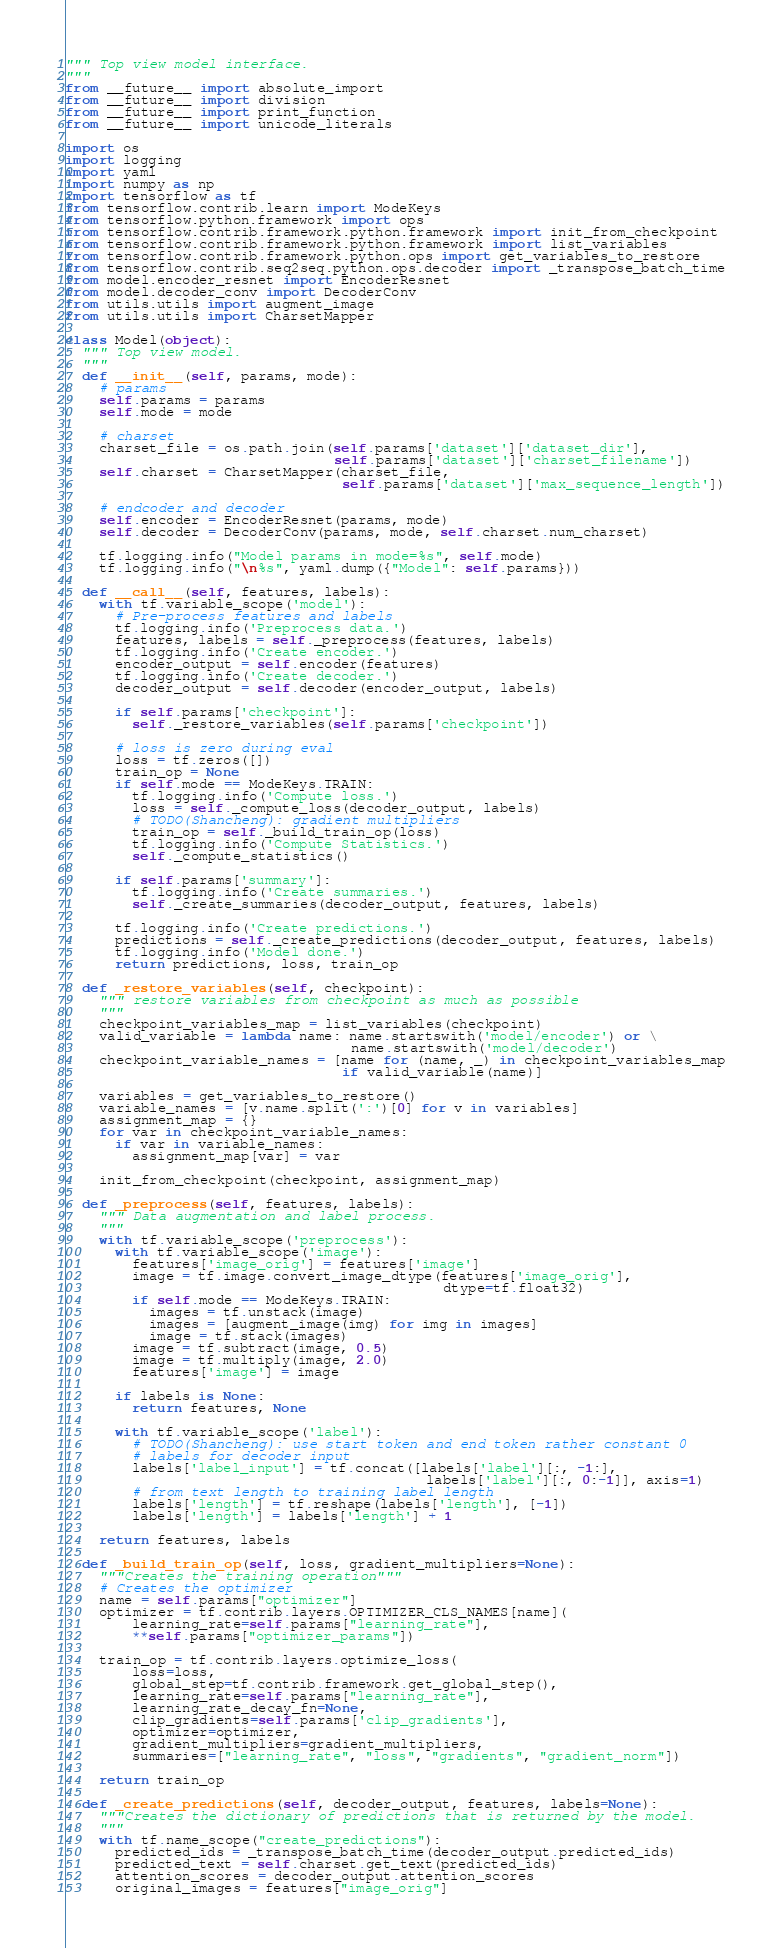<code> <loc_0><loc_0><loc_500><loc_500><_Python_>""" Top view model interface.
"""
from __future__ import absolute_import
from __future__ import division
from __future__ import print_function
from __future__ import unicode_literals

import os
import logging
import yaml
import numpy as np
import tensorflow as tf
from tensorflow.contrib.learn import ModeKeys
from tensorflow.python.framework import ops
from tensorflow.contrib.framework.python.framework import init_from_checkpoint
from tensorflow.contrib.framework.python.framework import list_variables
from tensorflow.contrib.framework.python.ops import get_variables_to_restore
from tensorflow.contrib.seq2seq.python.ops.decoder import _transpose_batch_time
from model.encoder_resnet import EncoderResnet
from model.decoder_conv import DecoderConv
from utils.utils import augment_image
from utils.utils import CharsetMapper

class Model(object):
  """ Top view model.
  """
  def __init__(self, params, mode):
    # params
    self.params = params
    self.mode = mode

    # charset
    charset_file = os.path.join(self.params['dataset']['dataset_dir'],
                                self.params['dataset']['charset_filename'])
    self.charset = CharsetMapper(charset_file,
                                 self.params['dataset']['max_sequence_length'])

    # endcoder and decoder
    self.encoder = EncoderResnet(params, mode)
    self.decoder = DecoderConv(params, mode, self.charset.num_charset)

    tf.logging.info("Model params in mode=%s", self.mode)
    tf.logging.info("\n%s", yaml.dump({"Model": self.params}))

  def __call__(self, features, labels):
    with tf.variable_scope('model'):
      # Pre-process features and labels
      tf.logging.info('Preprocess data.')
      features, labels = self._preprocess(features, labels)
      tf.logging.info('Create encoder.')
      encoder_output = self.encoder(features)
      tf.logging.info('Create decoder.')
      decoder_output = self.decoder(encoder_output, labels)

      if self.params['checkpoint']:
        self._restore_variables(self.params['checkpoint'])

      # loss is zero during eval
      loss = tf.zeros([])
      train_op = None
      if self.mode == ModeKeys.TRAIN:
        tf.logging.info('Compute loss.')
        loss = self._compute_loss(decoder_output, labels)
        # TODO(Shancheng): gradient multipliers
        train_op = self._build_train_op(loss)
        tf.logging.info('Compute Statistics.')
        self._compute_statistics()

      if self.params['summary']:
        tf.logging.info('Create summaries.')
        self._create_summaries(decoder_output, features, labels)

      tf.logging.info('Create predictions.')
      predictions = self._create_predictions(decoder_output, features, labels)
      tf.logging.info('Model done.')
      return predictions, loss, train_op

  def _restore_variables(self, checkpoint):
    """ restore variables from checkpoint as much as possible
    """
    checkpoint_variables_map = list_variables(checkpoint)
    valid_variable = lambda name: name.startswith('model/encoder') or \
                                  name.startswith('model/decoder')
    checkpoint_variable_names = [name for (name, _) in checkpoint_variables_map
                                 if valid_variable(name)]

    variables = get_variables_to_restore()
    variable_names = [v.name.split(':')[0] for v in variables]
    assignment_map = {}
    for var in checkpoint_variable_names:
      if var in variable_names:
        assignment_map[var] = var

    init_from_checkpoint(checkpoint, assignment_map)

  def _preprocess(self, features, labels):
    """ Data augmentation and label process.
    """
    with tf.variable_scope('preprocess'):
      with tf.variable_scope('image'):
        features['image_orig'] = features['image']
        image = tf.image.convert_image_dtype(features['image_orig'],
                                             dtype=tf.float32)
        if self.mode == ModeKeys.TRAIN:
          images = tf.unstack(image)
          images = [augment_image(img) for img in images]
          image = tf.stack(images)
        image = tf.subtract(image, 0.5)
        image = tf.multiply(image, 2.0)
        features['image'] = image

      if labels is None:
        return features, None

      with tf.variable_scope('label'):
        # TODO(Shancheng): use start token and end token rather constant 0
        # labels for decoder input
        labels['label_input'] = tf.concat([labels['label'][:, -1:],
                                           labels['label'][:, 0:-1]], axis=1)
        # from text length to training label length
        labels['length'] = tf.reshape(labels['length'], [-1])
        labels['length'] = labels['length'] + 1

    return features, labels

  def _build_train_op(self, loss, gradient_multipliers=None):
    """Creates the training operation"""
    # Creates the optimizer
    name = self.params["optimizer"]
    optimizer = tf.contrib.layers.OPTIMIZER_CLS_NAMES[name](
        learning_rate=self.params["learning_rate"],
        **self.params["optimizer_params"])

    train_op = tf.contrib.layers.optimize_loss(
        loss=loss,
        global_step=tf.contrib.framework.get_global_step(),
        learning_rate=self.params["learning_rate"],
        learning_rate_decay_fn=None,
        clip_gradients=self.params['clip_gradients'],
        optimizer=optimizer,
        gradient_multipliers=gradient_multipliers,
        summaries=["learning_rate", "loss", "gradients", "gradient_norm"])

    return train_op

  def _create_predictions(self, decoder_output, features, labels=None):
    """Creates the dictionary of predictions that is returned by the model.
    """
    with tf.name_scope("create_predictions"):
      predicted_ids = _transpose_batch_time(decoder_output.predicted_ids)
      predicted_text = self.charset.get_text(predicted_ids)
      attention_scores = decoder_output.attention_scores
      original_images = features["image_orig"]</code> 